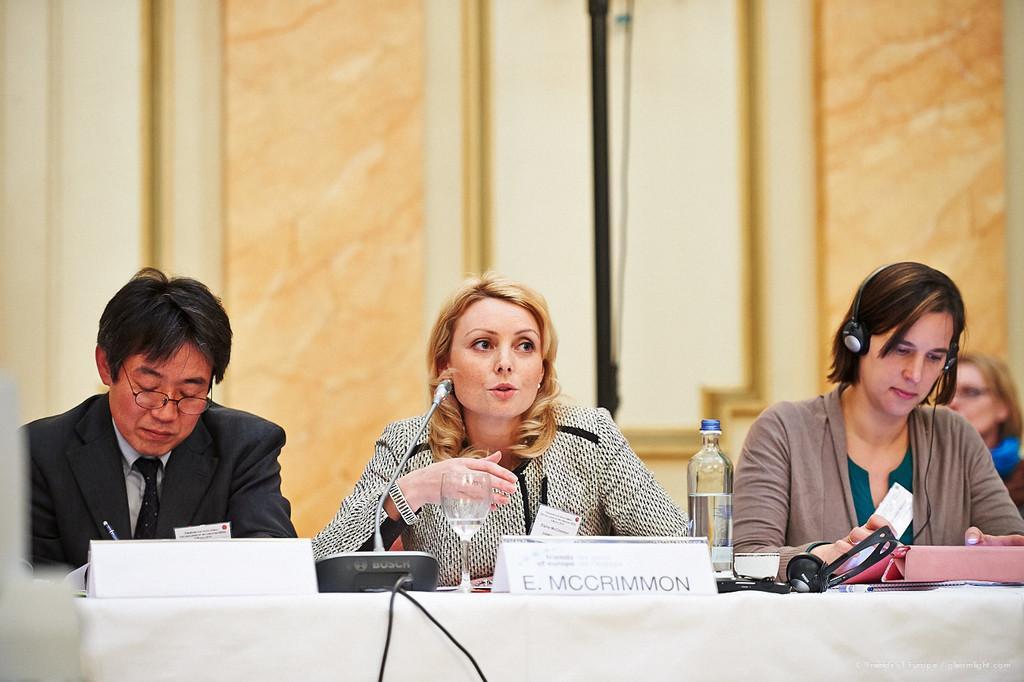Please provide a concise description of this image. This picture is clicked in the conference hall. The woman in the middle of the picture is sitting on the chair. She is talking on the microphone. Beside her, the woman in brown jacket is wearing a headset. On the left side, the man in black blazer who is wearing spectacles is holding a pen in his hand and he is writing something. In front of them, we see a table on which microphone, water glass, water bottle, file and name boards are placed. On the right side, we see a woman is sitting on the chair. Behind them, we see a wall. 